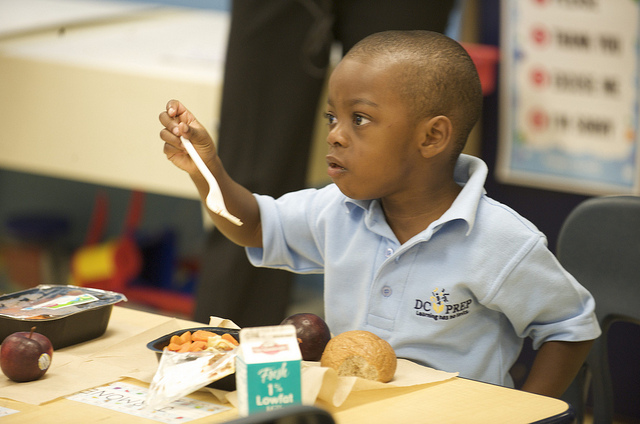Identify and read out the text in this image. DC PREP if 